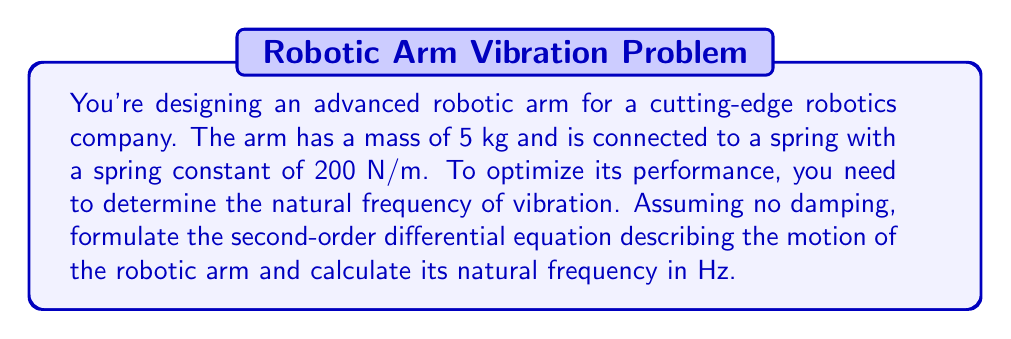Provide a solution to this math problem. Let's approach this step-by-step:

1) The second-order differential equation for a spring-mass system without damping is:

   $$m\frac{d^2x}{dt^2} + kx = 0$$

   where $m$ is the mass, $k$ is the spring constant, and $x$ is the displacement.

2) We're given:
   $m = 5$ kg
   $k = 200$ N/m

3) Substituting these values into our equation:

   $$5\frac{d^2x}{dt^2} + 200x = 0$$

4) To find the natural frequency, we need to put this equation in the standard form:

   $$\frac{d^2x}{dt^2} + \omega_n^2x = 0$$

   where $\omega_n$ is the natural angular frequency in radians per second.

5) Comparing our equation to the standard form:

   $$\frac{d^2x}{dt^2} + \frac{200}{5}x = 0$$

6) We can see that $\omega_n^2 = \frac{200}{5} = 40$

7) Therefore, $\omega_n = \sqrt{40} = 2\sqrt{10}$ rad/s

8) To convert from angular frequency (rad/s) to frequency (Hz), we use the formula:

   $$f = \frac{\omega_n}{2\pi}$$

9) Substituting our value:

   $$f = \frac{2\sqrt{10}}{2\pi} = \frac{\sqrt{10}}{\pi} \approx 1.0055 \text{ Hz}$$
Answer: The natural frequency of vibration for the robotic arm is $\frac{\sqrt{10}}{\pi}$ Hz, or approximately 1.0055 Hz. 